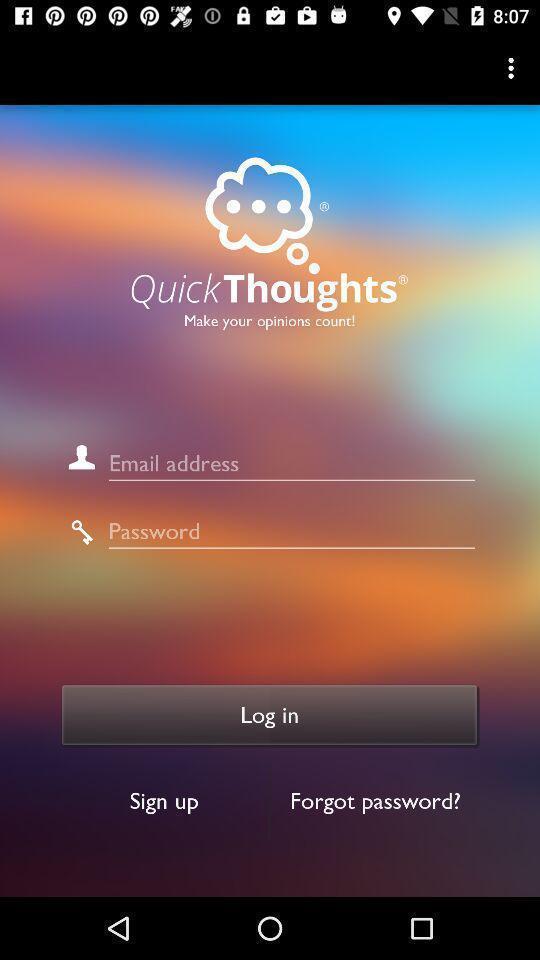Describe the visual elements of this screenshot. Screen showing log in page. 